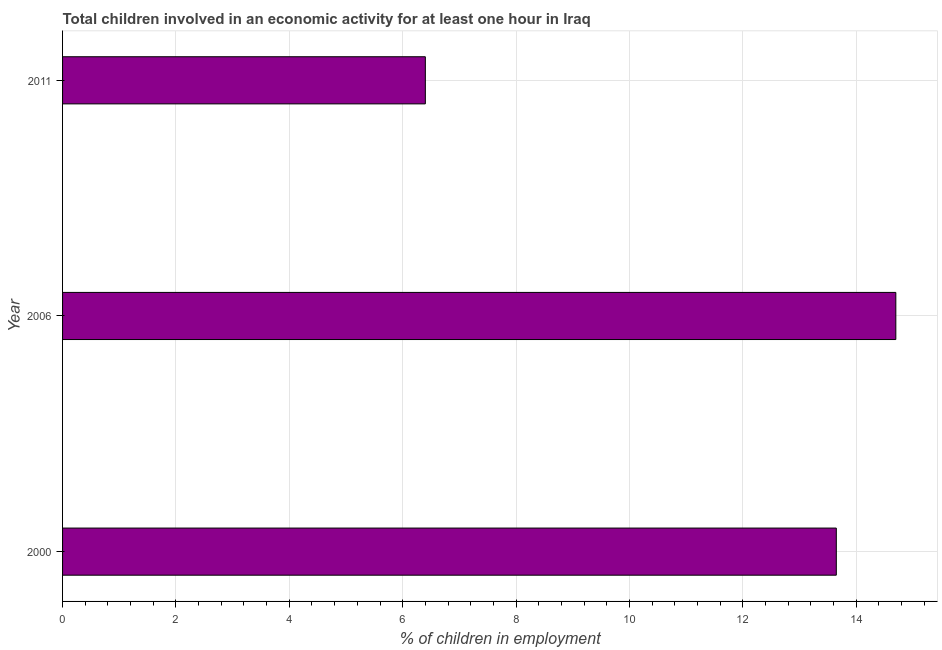Does the graph contain any zero values?
Your response must be concise. No. Does the graph contain grids?
Make the answer very short. Yes. What is the title of the graph?
Keep it short and to the point. Total children involved in an economic activity for at least one hour in Iraq. What is the label or title of the X-axis?
Offer a terse response. % of children in employment. What is the percentage of children in employment in 2000?
Your answer should be compact. 13.65. Across all years, what is the minimum percentage of children in employment?
Ensure brevity in your answer.  6.4. In which year was the percentage of children in employment maximum?
Your response must be concise. 2006. What is the sum of the percentage of children in employment?
Give a very brief answer. 34.75. What is the difference between the percentage of children in employment in 2000 and 2011?
Your response must be concise. 7.25. What is the average percentage of children in employment per year?
Ensure brevity in your answer.  11.58. What is the median percentage of children in employment?
Keep it short and to the point. 13.65. In how many years, is the percentage of children in employment greater than 1.2 %?
Provide a short and direct response. 3. What is the ratio of the percentage of children in employment in 2000 to that in 2011?
Make the answer very short. 2.13. Is the difference between the percentage of children in employment in 2006 and 2011 greater than the difference between any two years?
Offer a very short reply. Yes. What is the difference between the highest and the second highest percentage of children in employment?
Offer a very short reply. 1.05. Is the sum of the percentage of children in employment in 2000 and 2006 greater than the maximum percentage of children in employment across all years?
Make the answer very short. Yes. How many bars are there?
Your answer should be compact. 3. Are all the bars in the graph horizontal?
Your answer should be very brief. Yes. How many years are there in the graph?
Make the answer very short. 3. Are the values on the major ticks of X-axis written in scientific E-notation?
Your answer should be compact. No. What is the % of children in employment of 2000?
Offer a terse response. 13.65. What is the % of children in employment in 2006?
Make the answer very short. 14.7. What is the % of children in employment in 2011?
Your answer should be compact. 6.4. What is the difference between the % of children in employment in 2000 and 2006?
Your response must be concise. -1.05. What is the difference between the % of children in employment in 2000 and 2011?
Give a very brief answer. 7.25. What is the ratio of the % of children in employment in 2000 to that in 2006?
Your answer should be compact. 0.93. What is the ratio of the % of children in employment in 2000 to that in 2011?
Your answer should be very brief. 2.13. What is the ratio of the % of children in employment in 2006 to that in 2011?
Give a very brief answer. 2.3. 